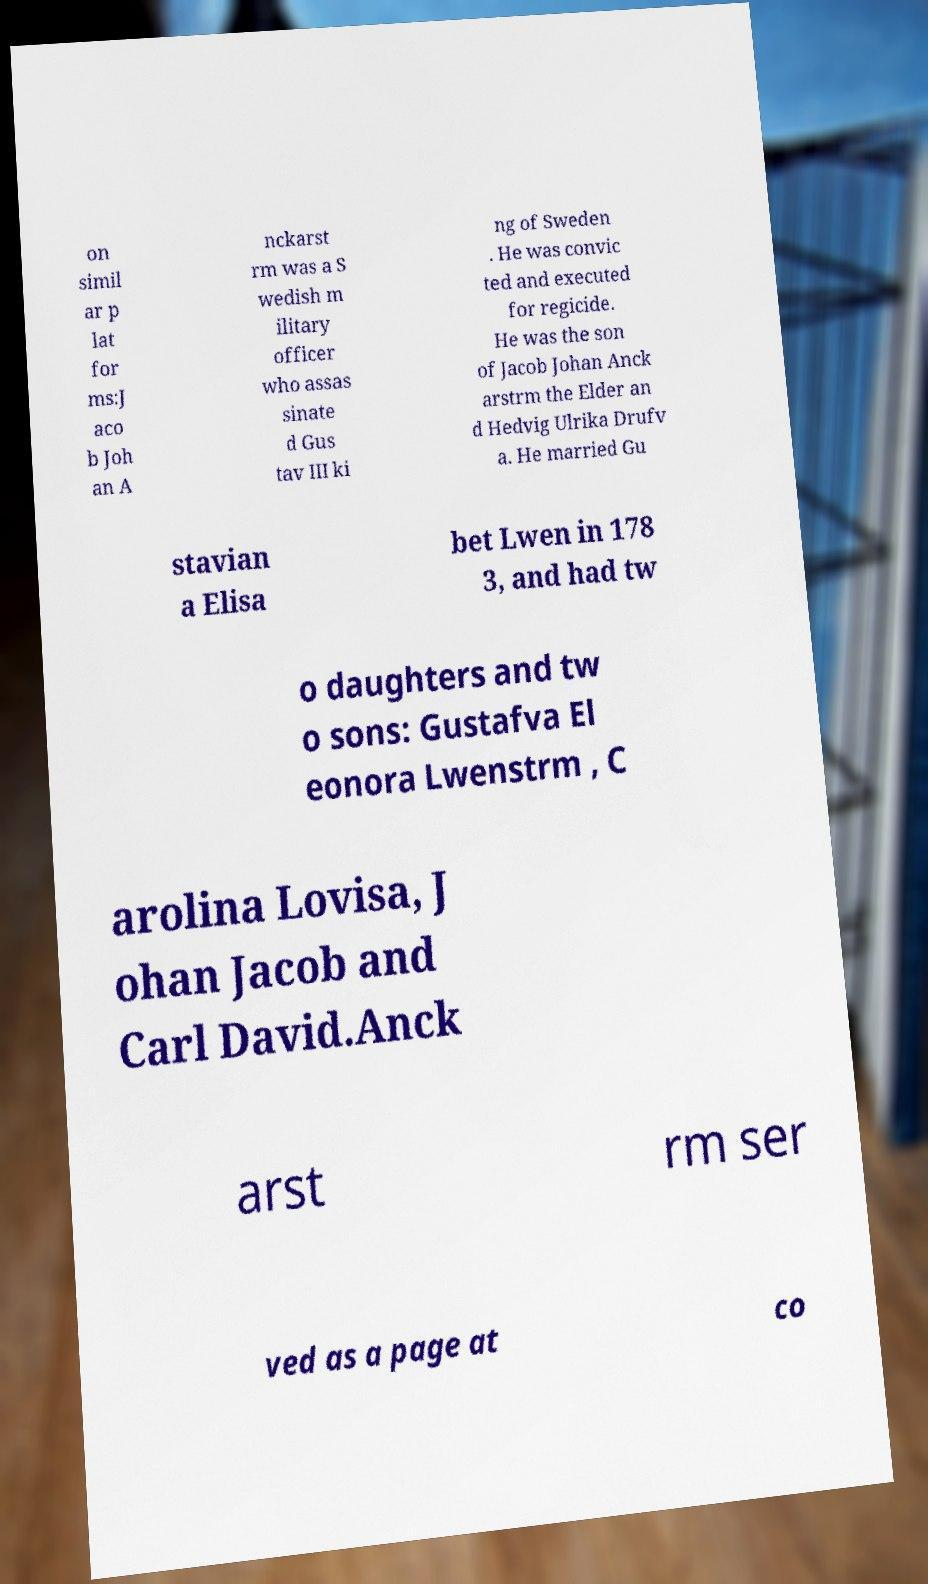Can you accurately transcribe the text from the provided image for me? on simil ar p lat for ms:J aco b Joh an A nckarst rm was a S wedish m ilitary officer who assas sinate d Gus tav III ki ng of Sweden . He was convic ted and executed for regicide. He was the son of Jacob Johan Anck arstrm the Elder an d Hedvig Ulrika Drufv a. He married Gu stavian a Elisa bet Lwen in 178 3, and had tw o daughters and tw o sons: Gustafva El eonora Lwenstrm , C arolina Lovisa, J ohan Jacob and Carl David.Anck arst rm ser ved as a page at co 